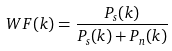Convert formula to latex. <formula><loc_0><loc_0><loc_500><loc_500>W F ( k ) = \frac { P _ { s } ( k ) } { P _ { s } ( k ) + P _ { n } ( k ) }</formula> 